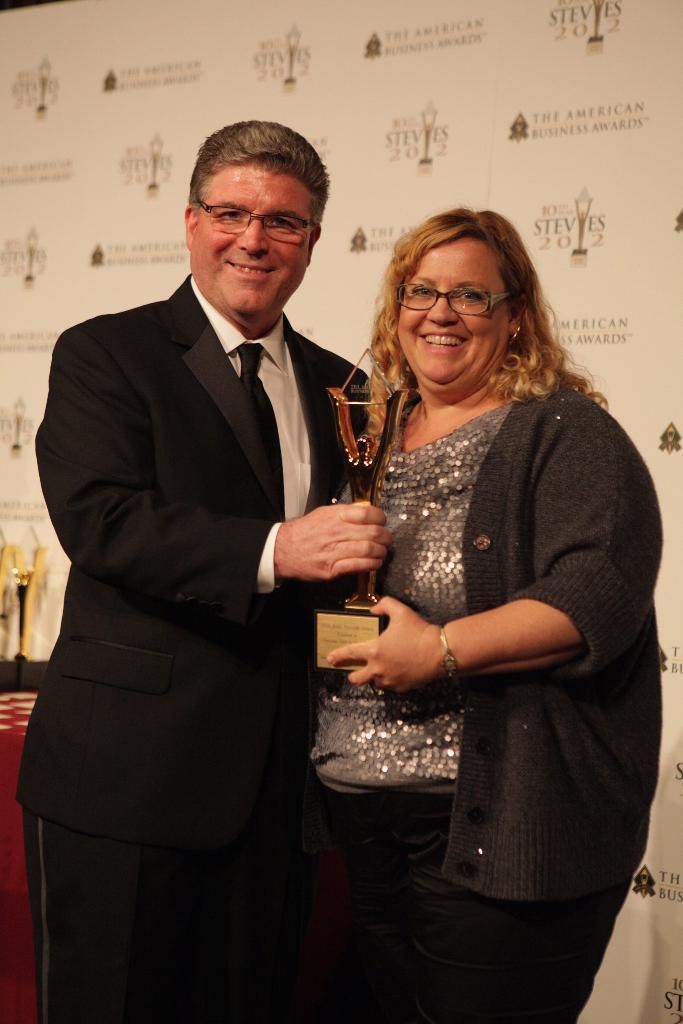What is the man in the image wearing? The man is wearing a suit. What is the woman in the image doing? The woman is smiling. What is the woman holding in the image? The woman is holding a prize in her hands. How many pigs can be seen in the image? There are no pigs present in the image. What type of earth is visible in the image? There is no reference to earth or soil in the image. 